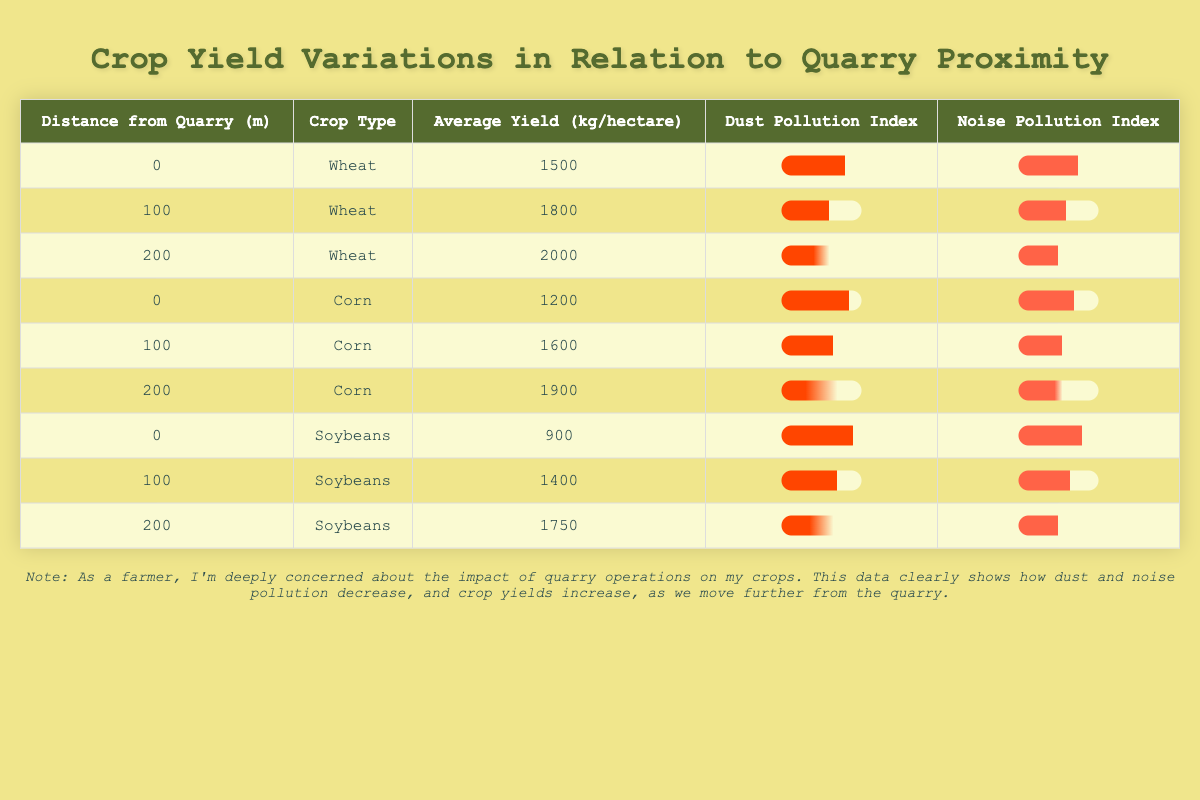What is the average yield of wheat at a distance of 200 meters from the quarry? The yield of wheat at 200 meters is 2000 kg per hectare. There is only one data point for wheat at this distance, so the average yield is simply 2000 kg per hectare.
Answer: 2000 kg/hectare How much does the dust pollution index decrease from 0 meters to 200 meters for corn? The dust pollution index for corn at 0 meters is 85, and at 200 meters it is 30. To find the decrease, subtract 30 from 85: 85 - 30 = 55.
Answer: 55 Is the average yield of soybeans greater than or equal to 1400 kg per hectare when grown at 100 meters from the quarry? At 100 meters, the average yield of soybeans is 1400 kg per hectare, which is equal to 1400. Therefore, the answer is yes.
Answer: Yes What is the difference in average yield between corn grown at 0 meters and corn grown at 200 meters from the quarry? The average yield for corn at 0 meters is 1200 kg per hectare, and at 200 meters it is 1900 kg per hectare. To find the difference: 1900 - 1200 = 700 kg per hectare.
Answer: 700 kg/hectare How does the noise pollution index change for wheat as the distance from the quarry increases from 0 to 200 meters? For wheat, the noise pollution index at 0 meters is 75, and at 200 meters, it is 50. To find the change, subtract 50 from 75: 75 - 50 = 25. Thus, the noise pollution index decreases by 25.
Answer: Decreases by 25 What is the average yield of all crops at a distance of 100 meters from the quarry? At 100 meters, the yields for the three crops are 1800 (Wheat) + 1600 (Corn) + 1400 (Soybeans) = 5000 kg. There are three crops, so the average yield is 5000 / 3 = 1666.67 kg per hectare.
Answer: 1666.67 kg/hectare Is the dust pollution index for soybeans at 0 meters higher than for corn at the same distance? The dust pollution index for soybeans at 0 meters is 90, and for corn at 0 meters, it is 85. Since 90 is greater than 85, the answer is yes.
Answer: Yes What crop type exhibits the highest average yield at 200 meters from the quarry? The average yields at 200 meters are 2000 kg for wheat, 1900 kg for corn, and 1750 kg for soybeans. Wheat has the highest yield among these, which is 2000 kg per hectare.
Answer: Wheat 